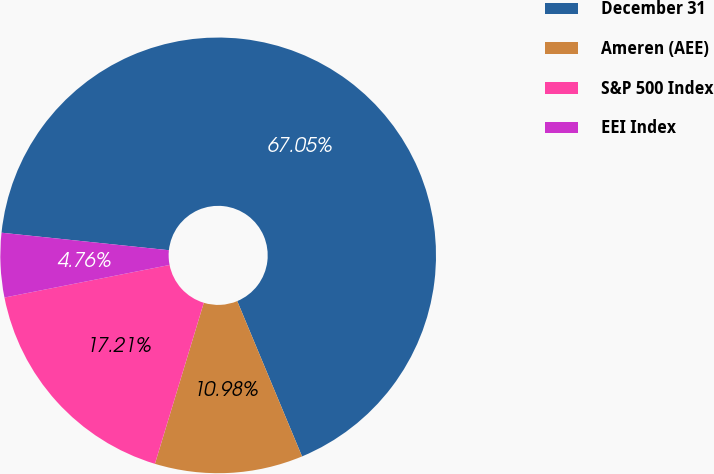Convert chart to OTSL. <chart><loc_0><loc_0><loc_500><loc_500><pie_chart><fcel>December 31<fcel>Ameren (AEE)<fcel>S&P 500 Index<fcel>EEI Index<nl><fcel>67.05%<fcel>10.98%<fcel>17.21%<fcel>4.76%<nl></chart> 